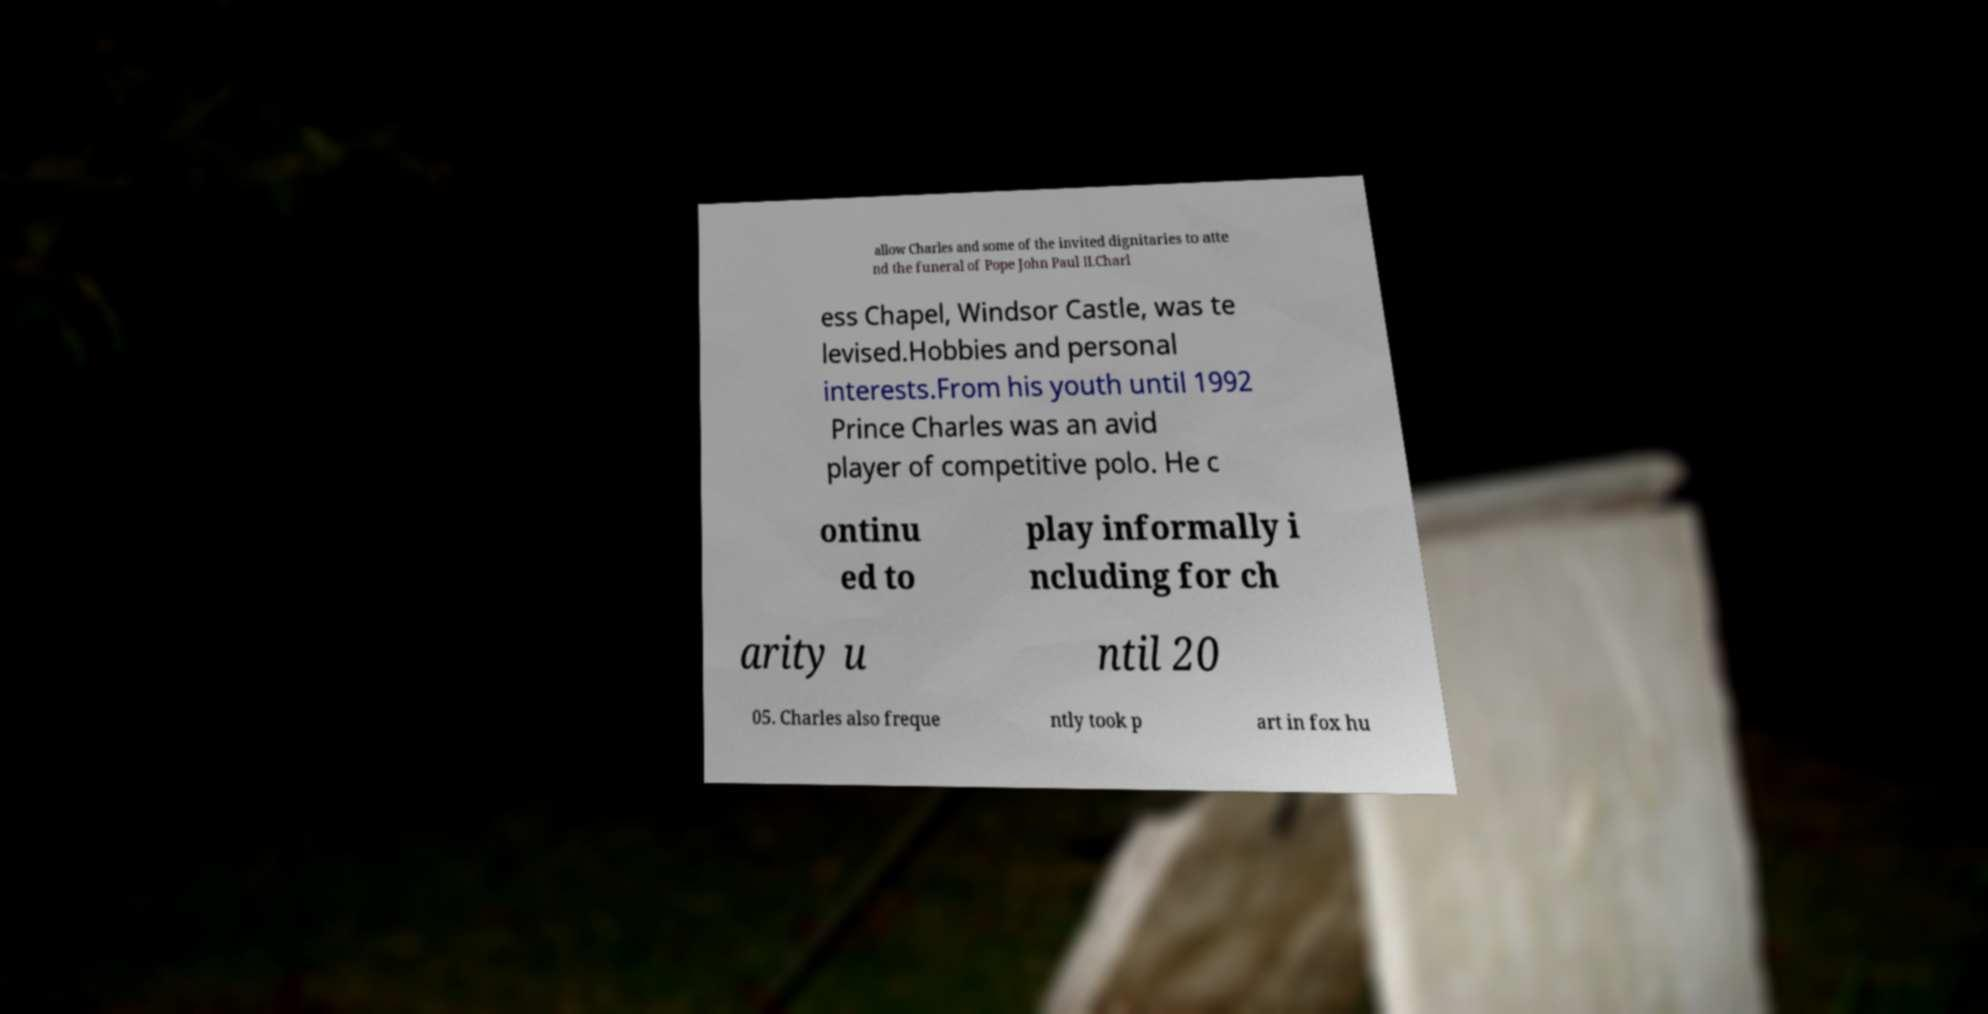There's text embedded in this image that I need extracted. Can you transcribe it verbatim? allow Charles and some of the invited dignitaries to atte nd the funeral of Pope John Paul II.Charl ess Chapel, Windsor Castle, was te levised.Hobbies and personal interests.From his youth until 1992 Prince Charles was an avid player of competitive polo. He c ontinu ed to play informally i ncluding for ch arity u ntil 20 05. Charles also freque ntly took p art in fox hu 